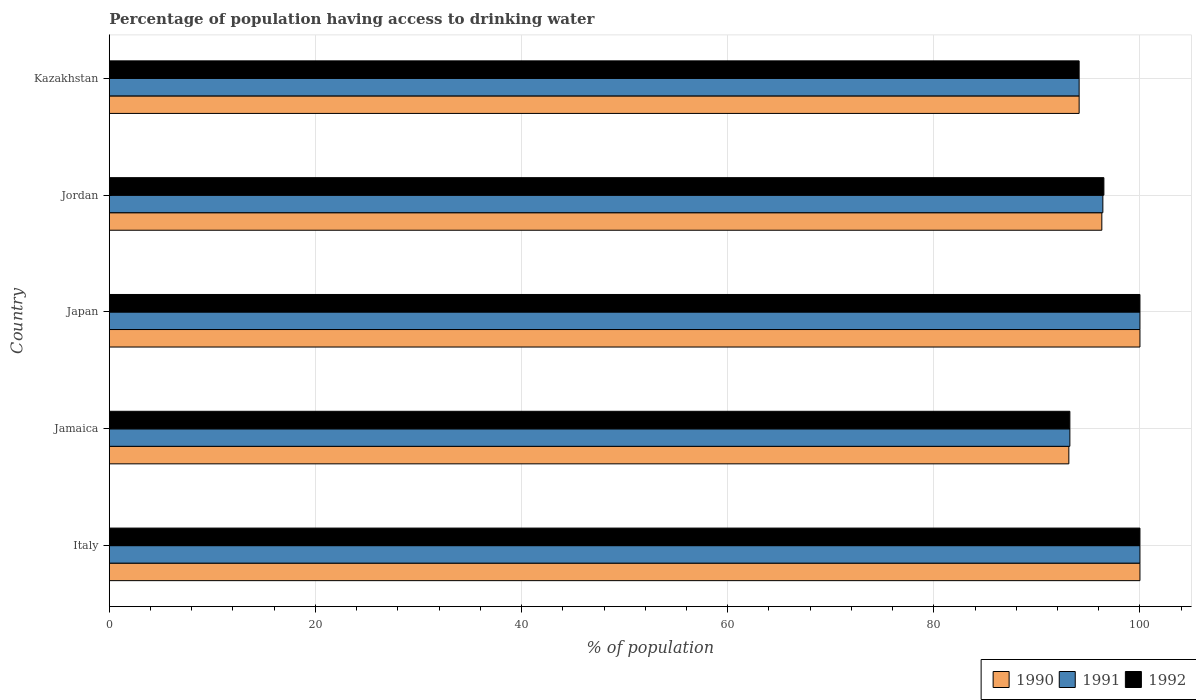Are the number of bars per tick equal to the number of legend labels?
Provide a short and direct response. Yes. How many bars are there on the 2nd tick from the top?
Offer a very short reply. 3. How many bars are there on the 4th tick from the bottom?
Make the answer very short. 3. What is the label of the 1st group of bars from the top?
Your answer should be compact. Kazakhstan. What is the percentage of population having access to drinking water in 1991 in Kazakhstan?
Keep it short and to the point. 94.1. Across all countries, what is the minimum percentage of population having access to drinking water in 1990?
Provide a succinct answer. 93.1. In which country was the percentage of population having access to drinking water in 1991 minimum?
Your answer should be very brief. Jamaica. What is the total percentage of population having access to drinking water in 1990 in the graph?
Ensure brevity in your answer.  483.5. What is the difference between the percentage of population having access to drinking water in 1991 in Japan and that in Jordan?
Your answer should be very brief. 3.6. What is the average percentage of population having access to drinking water in 1990 per country?
Make the answer very short. 96.7. What is the ratio of the percentage of population having access to drinking water in 1992 in Jordan to that in Kazakhstan?
Give a very brief answer. 1.03. Is the percentage of population having access to drinking water in 1990 in Jamaica less than that in Japan?
Keep it short and to the point. Yes. Is the difference between the percentage of population having access to drinking water in 1991 in Japan and Kazakhstan greater than the difference between the percentage of population having access to drinking water in 1990 in Japan and Kazakhstan?
Offer a terse response. No. What is the difference between the highest and the second highest percentage of population having access to drinking water in 1990?
Offer a terse response. 0. What is the difference between the highest and the lowest percentage of population having access to drinking water in 1990?
Give a very brief answer. 6.9. In how many countries, is the percentage of population having access to drinking water in 1990 greater than the average percentage of population having access to drinking water in 1990 taken over all countries?
Your answer should be very brief. 2. Is the sum of the percentage of population having access to drinking water in 1992 in Japan and Kazakhstan greater than the maximum percentage of population having access to drinking water in 1990 across all countries?
Your answer should be compact. Yes. What does the 2nd bar from the top in Japan represents?
Provide a succinct answer. 1991. Is it the case that in every country, the sum of the percentage of population having access to drinking water in 1991 and percentage of population having access to drinking water in 1992 is greater than the percentage of population having access to drinking water in 1990?
Offer a terse response. Yes. How many bars are there?
Offer a very short reply. 15. What is the difference between two consecutive major ticks on the X-axis?
Your answer should be very brief. 20. Are the values on the major ticks of X-axis written in scientific E-notation?
Keep it short and to the point. No. How many legend labels are there?
Offer a very short reply. 3. What is the title of the graph?
Offer a terse response. Percentage of population having access to drinking water. Does "1973" appear as one of the legend labels in the graph?
Give a very brief answer. No. What is the label or title of the X-axis?
Your answer should be very brief. % of population. What is the % of population of 1990 in Jamaica?
Keep it short and to the point. 93.1. What is the % of population of 1991 in Jamaica?
Give a very brief answer. 93.2. What is the % of population in 1992 in Jamaica?
Your answer should be compact. 93.2. What is the % of population of 1991 in Japan?
Make the answer very short. 100. What is the % of population of 1990 in Jordan?
Offer a terse response. 96.3. What is the % of population of 1991 in Jordan?
Keep it short and to the point. 96.4. What is the % of population of 1992 in Jordan?
Your answer should be very brief. 96.5. What is the % of population of 1990 in Kazakhstan?
Make the answer very short. 94.1. What is the % of population in 1991 in Kazakhstan?
Your response must be concise. 94.1. What is the % of population in 1992 in Kazakhstan?
Ensure brevity in your answer.  94.1. Across all countries, what is the maximum % of population in 1991?
Offer a very short reply. 100. Across all countries, what is the minimum % of population of 1990?
Offer a terse response. 93.1. Across all countries, what is the minimum % of population of 1991?
Keep it short and to the point. 93.2. Across all countries, what is the minimum % of population in 1992?
Give a very brief answer. 93.2. What is the total % of population in 1990 in the graph?
Your response must be concise. 483.5. What is the total % of population in 1991 in the graph?
Your answer should be compact. 483.7. What is the total % of population of 1992 in the graph?
Your answer should be compact. 483.8. What is the difference between the % of population of 1992 in Italy and that in Jamaica?
Keep it short and to the point. 6.8. What is the difference between the % of population of 1992 in Italy and that in Japan?
Your response must be concise. 0. What is the difference between the % of population of 1991 in Italy and that in Jordan?
Ensure brevity in your answer.  3.6. What is the difference between the % of population in 1992 in Italy and that in Jordan?
Your answer should be compact. 3.5. What is the difference between the % of population of 1990 in Italy and that in Kazakhstan?
Keep it short and to the point. 5.9. What is the difference between the % of population in 1992 in Jamaica and that in Japan?
Make the answer very short. -6.8. What is the difference between the % of population in 1991 in Jamaica and that in Jordan?
Your answer should be very brief. -3.2. What is the difference between the % of population of 1990 in Jamaica and that in Kazakhstan?
Make the answer very short. -1. What is the difference between the % of population of 1991 in Jamaica and that in Kazakhstan?
Ensure brevity in your answer.  -0.9. What is the difference between the % of population in 1991 in Japan and that in Jordan?
Keep it short and to the point. 3.6. What is the difference between the % of population in 1992 in Japan and that in Jordan?
Offer a very short reply. 3.5. What is the difference between the % of population of 1991 in Japan and that in Kazakhstan?
Provide a short and direct response. 5.9. What is the difference between the % of population in 1992 in Japan and that in Kazakhstan?
Keep it short and to the point. 5.9. What is the difference between the % of population in 1991 in Jordan and that in Kazakhstan?
Make the answer very short. 2.3. What is the difference between the % of population in 1992 in Jordan and that in Kazakhstan?
Make the answer very short. 2.4. What is the difference between the % of population in 1990 in Italy and the % of population in 1991 in Jamaica?
Your answer should be very brief. 6.8. What is the difference between the % of population in 1990 in Italy and the % of population in 1991 in Japan?
Provide a succinct answer. 0. What is the difference between the % of population in 1991 in Italy and the % of population in 1992 in Japan?
Offer a very short reply. 0. What is the difference between the % of population in 1991 in Italy and the % of population in 1992 in Jordan?
Provide a short and direct response. 3.5. What is the difference between the % of population in 1990 in Italy and the % of population in 1992 in Kazakhstan?
Provide a succinct answer. 5.9. What is the difference between the % of population in 1991 in Italy and the % of population in 1992 in Kazakhstan?
Provide a succinct answer. 5.9. What is the difference between the % of population of 1990 in Jamaica and the % of population of 1991 in Japan?
Offer a very short reply. -6.9. What is the difference between the % of population in 1990 in Jamaica and the % of population in 1992 in Japan?
Provide a succinct answer. -6.9. What is the difference between the % of population in 1990 in Jamaica and the % of population in 1992 in Jordan?
Your answer should be compact. -3.4. What is the difference between the % of population in 1990 in Jamaica and the % of population in 1991 in Kazakhstan?
Offer a very short reply. -1. What is the difference between the % of population of 1990 in Japan and the % of population of 1991 in Jordan?
Ensure brevity in your answer.  3.6. What is the difference between the % of population in 1991 in Japan and the % of population in 1992 in Jordan?
Your response must be concise. 3.5. What is the difference between the % of population of 1990 in Japan and the % of population of 1991 in Kazakhstan?
Provide a succinct answer. 5.9. What is the difference between the % of population of 1990 in Jordan and the % of population of 1991 in Kazakhstan?
Ensure brevity in your answer.  2.2. What is the difference between the % of population in 1991 in Jordan and the % of population in 1992 in Kazakhstan?
Your answer should be compact. 2.3. What is the average % of population of 1990 per country?
Give a very brief answer. 96.7. What is the average % of population in 1991 per country?
Offer a very short reply. 96.74. What is the average % of population in 1992 per country?
Keep it short and to the point. 96.76. What is the difference between the % of population of 1990 and % of population of 1991 in Italy?
Keep it short and to the point. 0. What is the difference between the % of population of 1991 and % of population of 1992 in Italy?
Offer a very short reply. 0. What is the difference between the % of population in 1990 and % of population in 1992 in Japan?
Provide a succinct answer. 0. What is the difference between the % of population of 1990 and % of population of 1991 in Jordan?
Provide a succinct answer. -0.1. What is the difference between the % of population of 1990 and % of population of 1992 in Jordan?
Make the answer very short. -0.2. What is the difference between the % of population in 1990 and % of population in 1991 in Kazakhstan?
Keep it short and to the point. 0. What is the difference between the % of population in 1990 and % of population in 1992 in Kazakhstan?
Provide a short and direct response. 0. What is the ratio of the % of population of 1990 in Italy to that in Jamaica?
Give a very brief answer. 1.07. What is the ratio of the % of population in 1991 in Italy to that in Jamaica?
Provide a succinct answer. 1.07. What is the ratio of the % of population in 1992 in Italy to that in Jamaica?
Provide a succinct answer. 1.07. What is the ratio of the % of population of 1990 in Italy to that in Japan?
Make the answer very short. 1. What is the ratio of the % of population of 1992 in Italy to that in Japan?
Offer a terse response. 1. What is the ratio of the % of population in 1990 in Italy to that in Jordan?
Provide a succinct answer. 1.04. What is the ratio of the % of population of 1991 in Italy to that in Jordan?
Your answer should be very brief. 1.04. What is the ratio of the % of population of 1992 in Italy to that in Jordan?
Offer a very short reply. 1.04. What is the ratio of the % of population of 1990 in Italy to that in Kazakhstan?
Keep it short and to the point. 1.06. What is the ratio of the % of population of 1991 in Italy to that in Kazakhstan?
Provide a succinct answer. 1.06. What is the ratio of the % of population of 1992 in Italy to that in Kazakhstan?
Provide a succinct answer. 1.06. What is the ratio of the % of population of 1991 in Jamaica to that in Japan?
Provide a succinct answer. 0.93. What is the ratio of the % of population in 1992 in Jamaica to that in Japan?
Give a very brief answer. 0.93. What is the ratio of the % of population in 1990 in Jamaica to that in Jordan?
Your answer should be compact. 0.97. What is the ratio of the % of population of 1991 in Jamaica to that in Jordan?
Your answer should be very brief. 0.97. What is the ratio of the % of population of 1992 in Jamaica to that in Jordan?
Give a very brief answer. 0.97. What is the ratio of the % of population in 1990 in Jamaica to that in Kazakhstan?
Your answer should be very brief. 0.99. What is the ratio of the % of population of 1992 in Jamaica to that in Kazakhstan?
Offer a terse response. 0.99. What is the ratio of the % of population in 1990 in Japan to that in Jordan?
Offer a very short reply. 1.04. What is the ratio of the % of population of 1991 in Japan to that in Jordan?
Give a very brief answer. 1.04. What is the ratio of the % of population of 1992 in Japan to that in Jordan?
Keep it short and to the point. 1.04. What is the ratio of the % of population of 1990 in Japan to that in Kazakhstan?
Provide a succinct answer. 1.06. What is the ratio of the % of population in 1991 in Japan to that in Kazakhstan?
Give a very brief answer. 1.06. What is the ratio of the % of population in 1992 in Japan to that in Kazakhstan?
Give a very brief answer. 1.06. What is the ratio of the % of population in 1990 in Jordan to that in Kazakhstan?
Your answer should be very brief. 1.02. What is the ratio of the % of population of 1991 in Jordan to that in Kazakhstan?
Keep it short and to the point. 1.02. What is the ratio of the % of population of 1992 in Jordan to that in Kazakhstan?
Make the answer very short. 1.03. What is the difference between the highest and the lowest % of population of 1992?
Give a very brief answer. 6.8. 